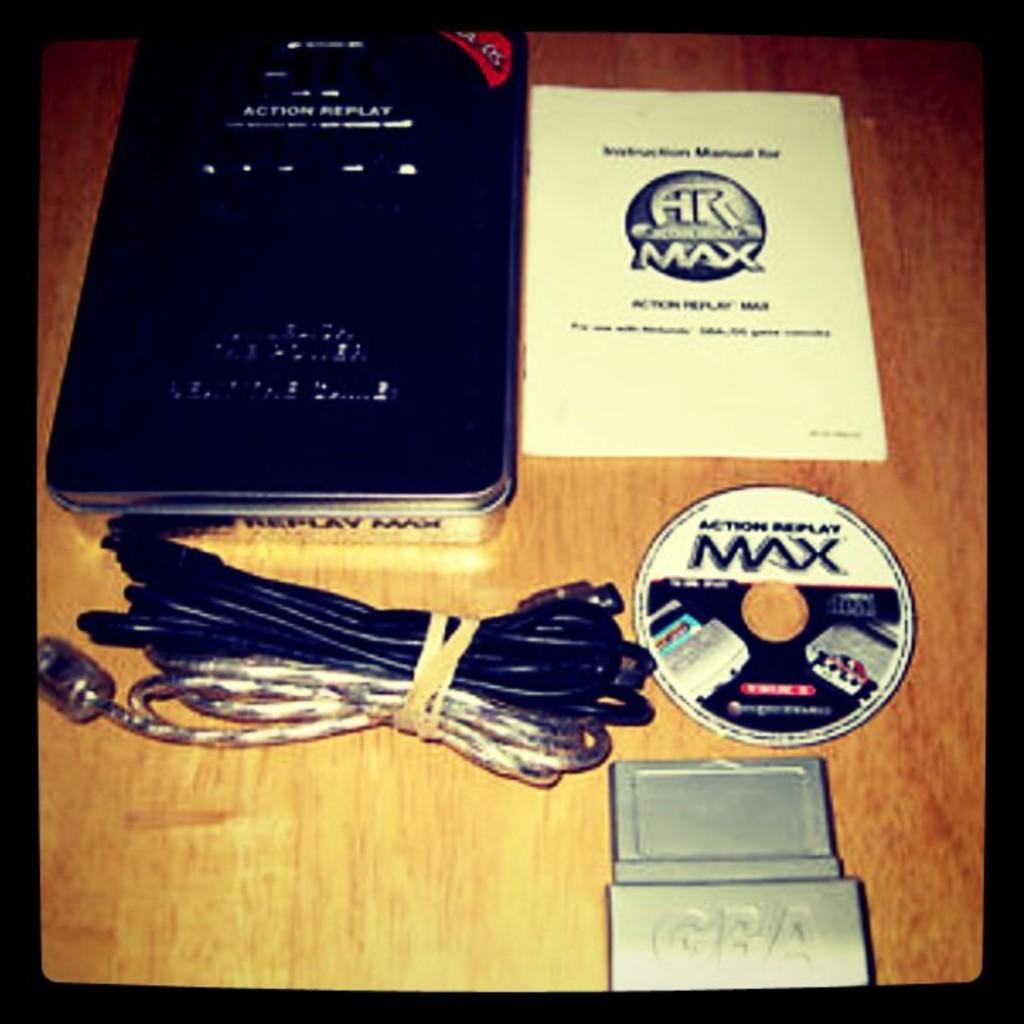What does the cd say?
Your answer should be very brief. Action replay max. 